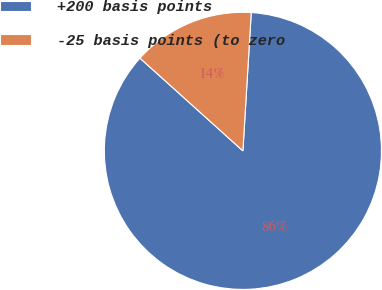<chart> <loc_0><loc_0><loc_500><loc_500><pie_chart><fcel>+200 basis points<fcel>-25 basis points (to zero<nl><fcel>85.71%<fcel>14.29%<nl></chart> 